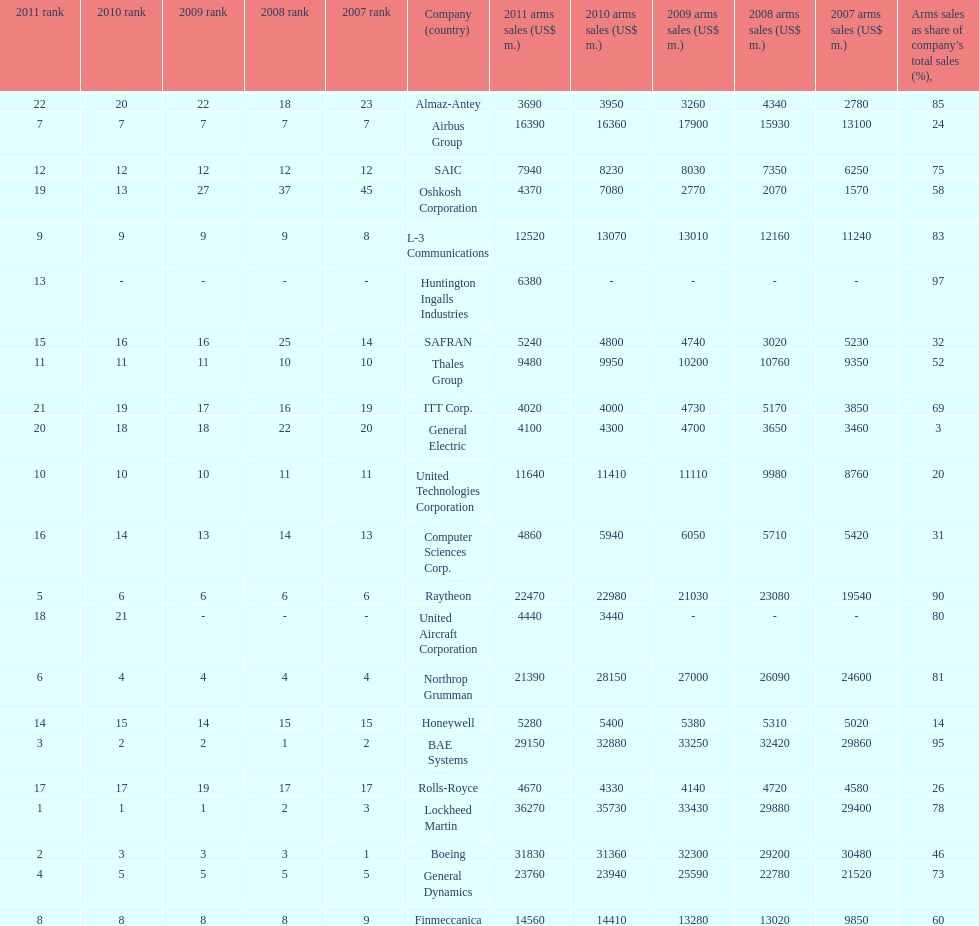How many different countries are listed? 6. 